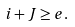Convert formula to latex. <formula><loc_0><loc_0><loc_500><loc_500>i + J \geq e .</formula> 